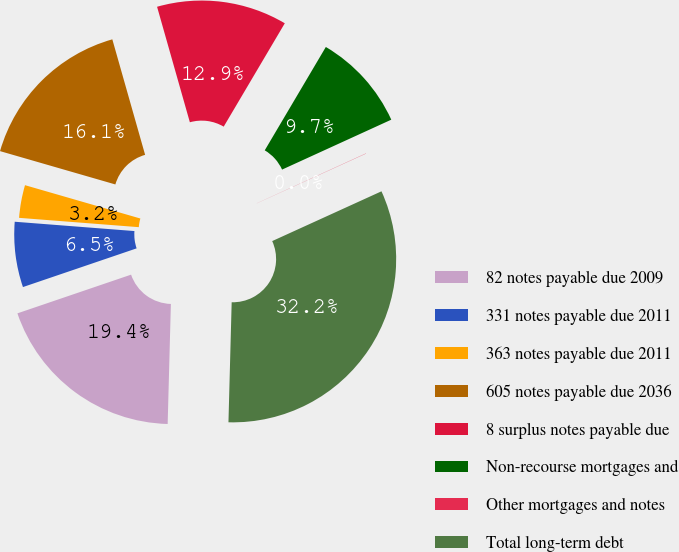Convert chart. <chart><loc_0><loc_0><loc_500><loc_500><pie_chart><fcel>82 notes payable due 2009<fcel>331 notes payable due 2011<fcel>363 notes payable due 2011<fcel>605 notes payable due 2036<fcel>8 surplus notes payable due<fcel>Non-recourse mortgages and<fcel>Other mortgages and notes<fcel>Total long-term debt<nl><fcel>19.35%<fcel>6.46%<fcel>3.24%<fcel>16.12%<fcel>12.9%<fcel>9.68%<fcel>0.02%<fcel>32.23%<nl></chart> 